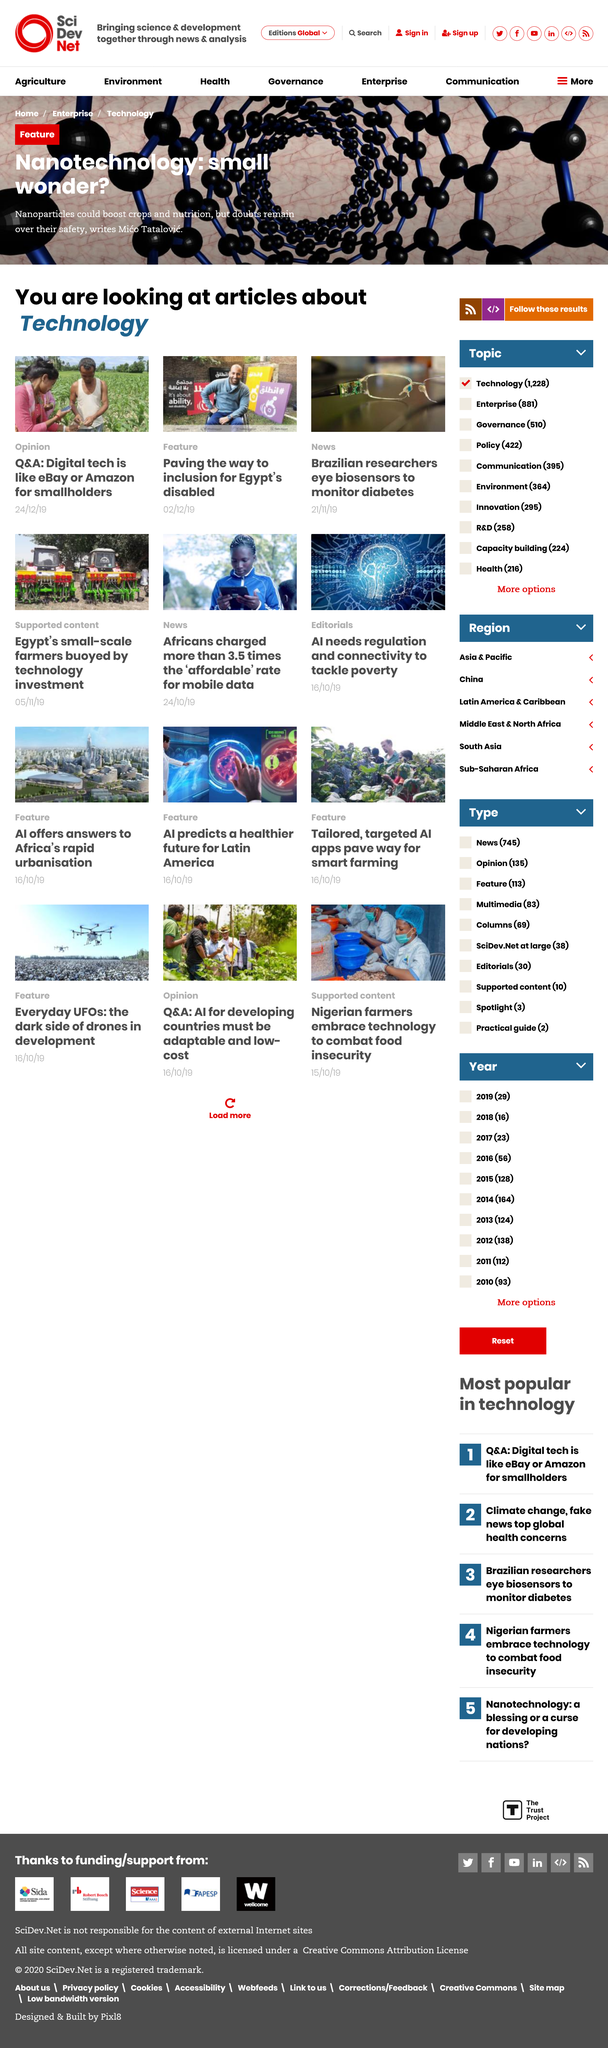Specify some key components in this picture. Nanoparticles have the potential to significantly enhance crop yields and nutritional content. Brazilian researchers are focused on developing biosensors to monitor diabetes. The article on paving the way for inclusion of Egypt's disabled falls under the Feature category. 